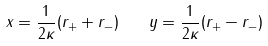Convert formula to latex. <formula><loc_0><loc_0><loc_500><loc_500>x = \frac { 1 } { 2 \kappa } ( r _ { + } + r _ { - } ) \quad y = \frac { 1 } { 2 \kappa } ( r _ { + } - r _ { - } )</formula> 